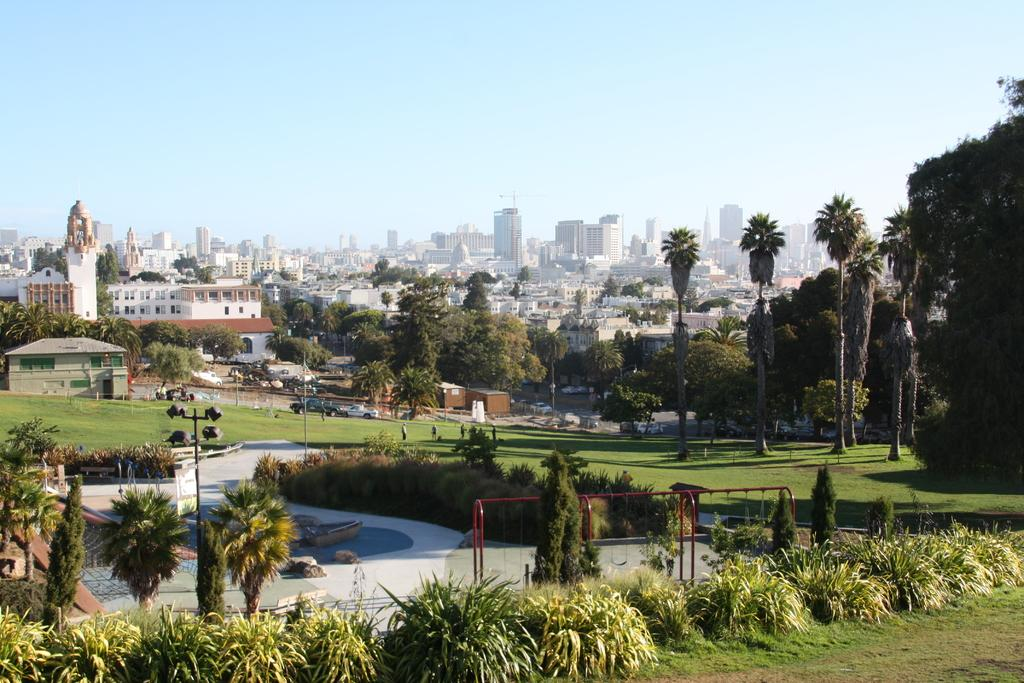What type of living organisms can be seen in the image? Plants are visible in the image. What material is used for the rods in the image? Metal rods are present in the image. What structures are visible in the image? Poles and buildings are visible in the image. What type of transportation can be seen in the image? Vehicles are in the image. Where are the people located in the image? People are on the grass in the image. What can be seen in the background of the image? Trees and buildings are visible in the background of the image. What type of soup is the grandmother eating in the image? There is no grandmother or soup present in the image. What is the account number of the person walking in the image? There is no mention of an account or account number in the image. 